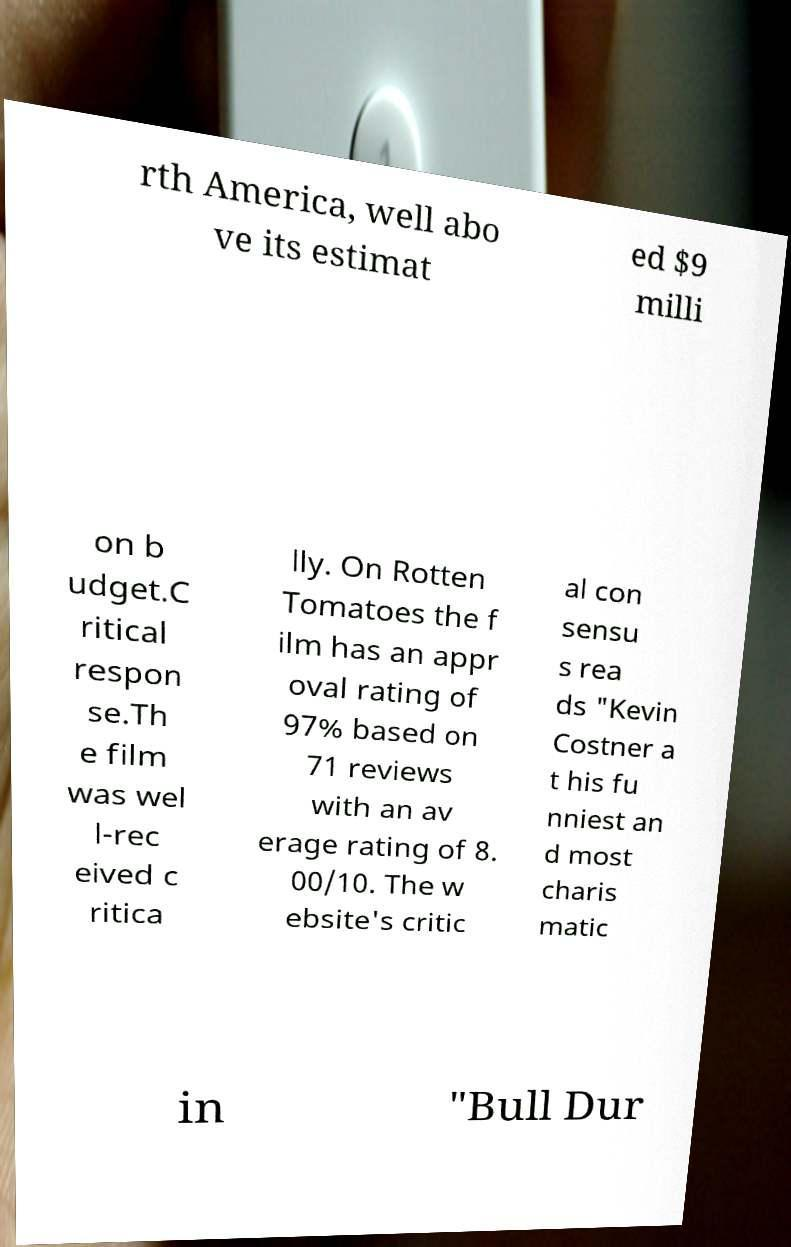Could you extract and type out the text from this image? rth America, well abo ve its estimat ed $9 milli on b udget.C ritical respon se.Th e film was wel l-rec eived c ritica lly. On Rotten Tomatoes the f ilm has an appr oval rating of 97% based on 71 reviews with an av erage rating of 8. 00/10. The w ebsite's critic al con sensu s rea ds "Kevin Costner a t his fu nniest an d most charis matic in "Bull Dur 